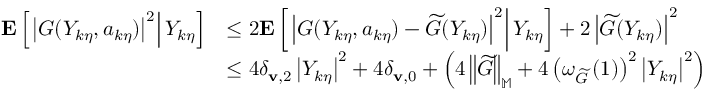Convert formula to latex. <formula><loc_0><loc_0><loc_500><loc_500>\begin{array} { r l } { E \left [ \left | G ( Y _ { k \eta } , a _ { k \eta } ) \right | ^ { 2 } \right | Y _ { k \eta } \right ] } & { \leq 2 E \left [ \left | G ( Y _ { k \eta } , a _ { k \eta } ) - \widetilde { G } ( Y _ { k \eta } ) \right | ^ { 2 } \right | Y _ { k \eta } \right ] + 2 \left | \widetilde { G } ( Y _ { k \eta } ) \right | ^ { 2 } } \\ & { \leq 4 \delta _ { v , 2 } \left | Y _ { k \eta } \right | ^ { 2 } + 4 \delta _ { v , 0 } + \left ( 4 \left \| \widetilde { G } \right \| _ { \mathbb { M } } + 4 \left ( \omega _ { \widetilde { G } } \left ( 1 \right ) \right ) ^ { 2 } \left | Y _ { k \eta } \right | ^ { 2 } \right ) } \end{array}</formula> 